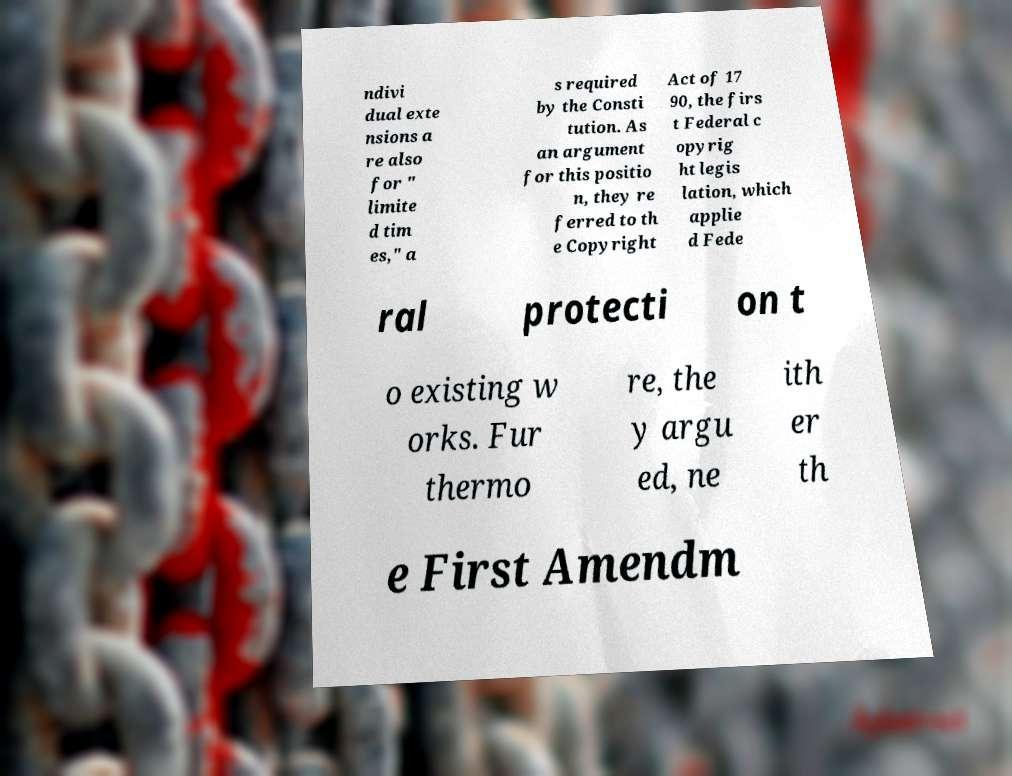Could you assist in decoding the text presented in this image and type it out clearly? ndivi dual exte nsions a re also for " limite d tim es," a s required by the Consti tution. As an argument for this positio n, they re ferred to th e Copyright Act of 17 90, the firs t Federal c opyrig ht legis lation, which applie d Fede ral protecti on t o existing w orks. Fur thermo re, the y argu ed, ne ith er th e First Amendm 